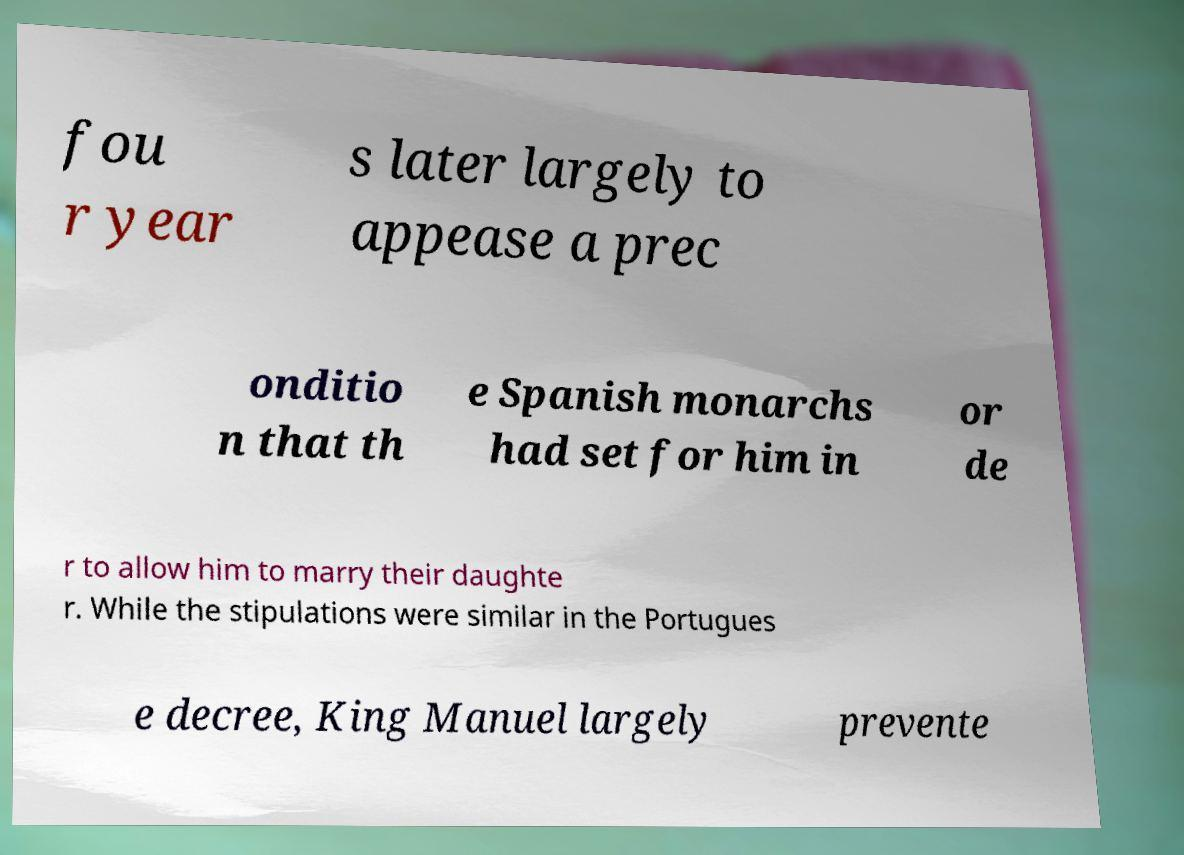Can you accurately transcribe the text from the provided image for me? fou r year s later largely to appease a prec onditio n that th e Spanish monarchs had set for him in or de r to allow him to marry their daughte r. While the stipulations were similar in the Portugues e decree, King Manuel largely prevente 